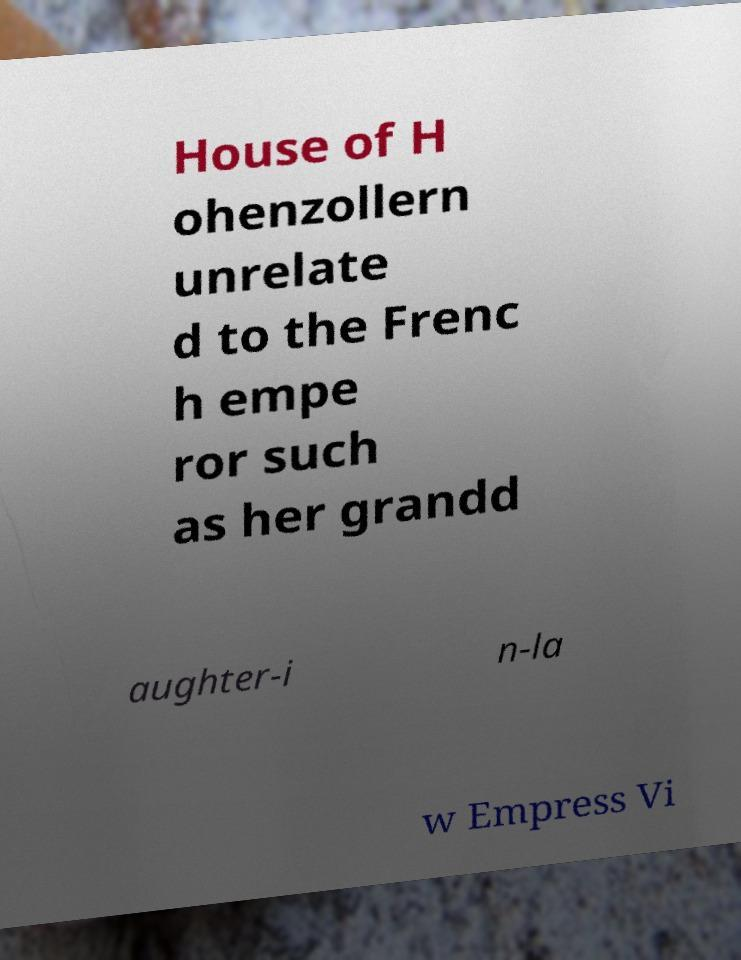I need the written content from this picture converted into text. Can you do that? House of H ohenzollern unrelate d to the Frenc h empe ror such as her grandd aughter-i n-la w Empress Vi 